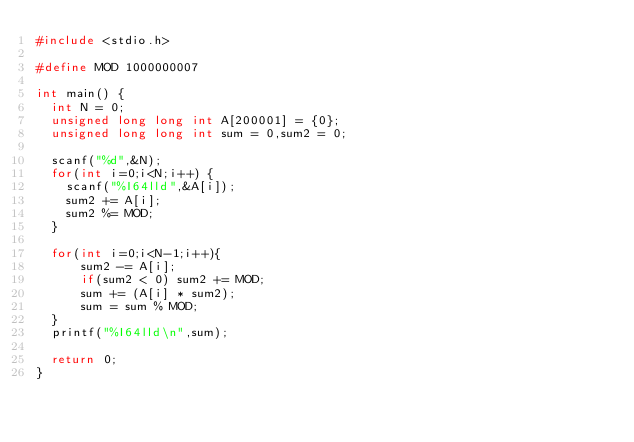<code> <loc_0><loc_0><loc_500><loc_500><_C_>#include <stdio.h>

#define MOD 1000000007

int main() {
  int N = 0;
  unsigned long long int A[200001] = {0};
  unsigned long long int sum = 0,sum2 = 0;

  scanf("%d",&N);
  for(int i=0;i<N;i++) {
    scanf("%I64lld",&A[i]);
    sum2 += A[i];
    sum2 %= MOD;
  }

  for(int i=0;i<N-1;i++){
      sum2 -= A[i];
      if(sum2 < 0) sum2 += MOD;
      sum += (A[i] * sum2);
      sum = sum % MOD;
  }
  printf("%I64lld\n",sum);

  return 0;
}
</code> 